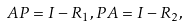<formula> <loc_0><loc_0><loc_500><loc_500>A P = I - R _ { 1 } , P A = I - R _ { 2 } ,</formula> 